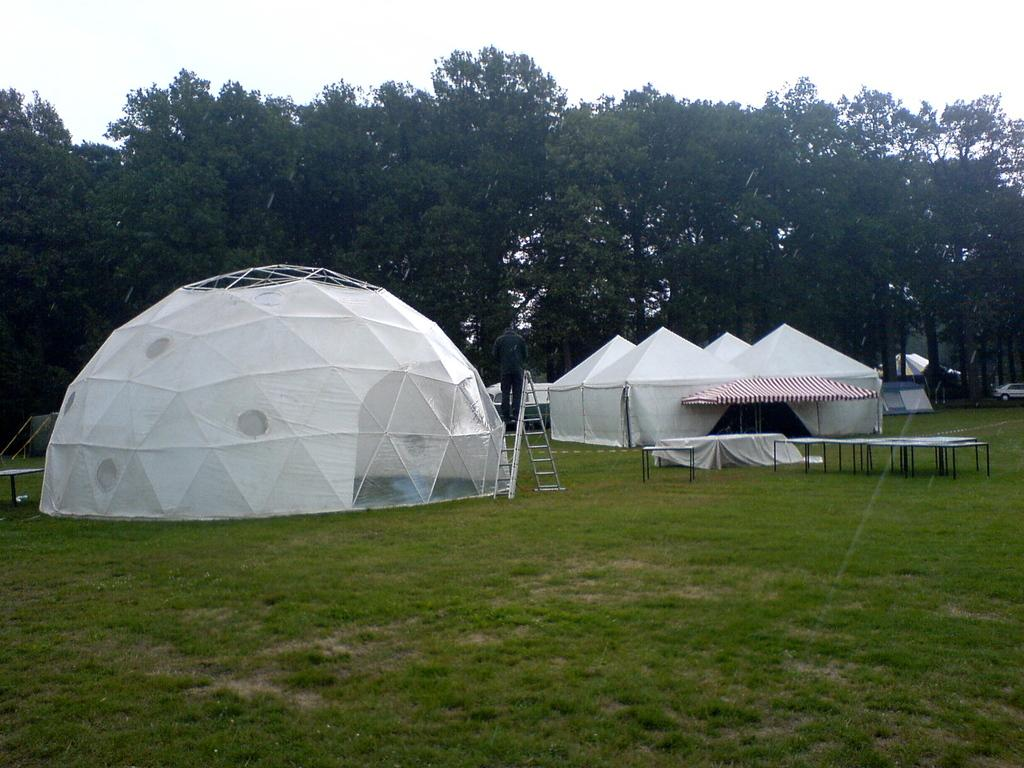What type of vegetation is present in the image? There are many trees in the image. What type of temporary shelters can be seen in the image? There are tents in the image. What part of the natural environment is visible in the image? The sky is visible in the image. What type of terrain is present in the image? There is a grassy land in the image. How many vehicles are visible in the image? There are few vehicles in the image. What arithmetic problem can be solved using the trees in the image? There is no arithmetic problem present in the image, as it features trees, tents, and vehicles. How many cows are grazing in the grassy land in the image? There are no cows present in the image; it features trees, tents, and vehicles. 